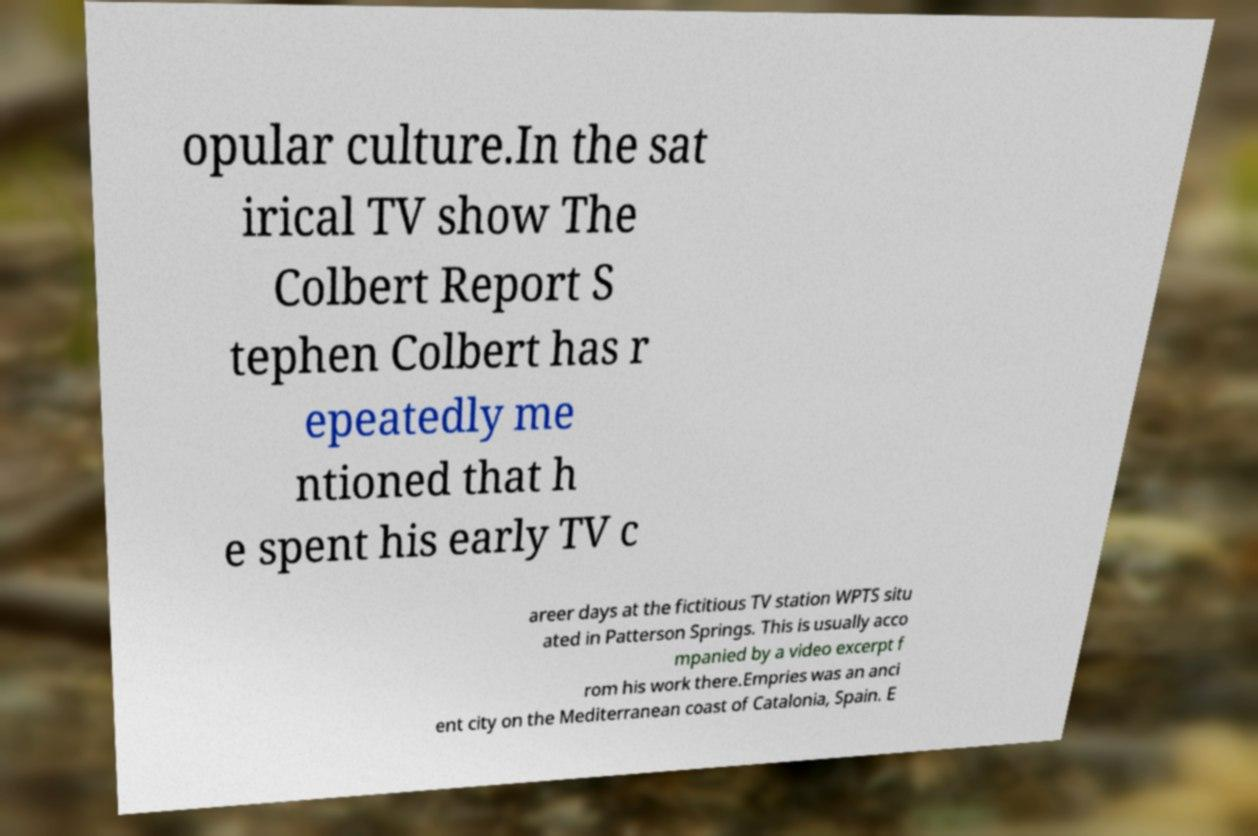There's text embedded in this image that I need extracted. Can you transcribe it verbatim? opular culture.In the sat irical TV show The Colbert Report S tephen Colbert has r epeatedly me ntioned that h e spent his early TV c areer days at the fictitious TV station WPTS situ ated in Patterson Springs. This is usually acco mpanied by a video excerpt f rom his work there.Empries was an anci ent city on the Mediterranean coast of Catalonia, Spain. E 